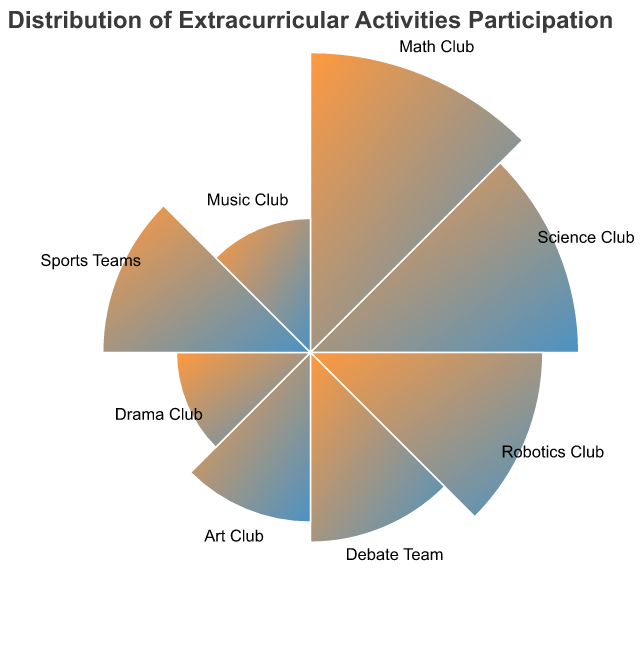What is the highest participation percentage? By examining the lengths of the radial sections, the Math Club has the highest participation rate of 25%.
Answer: 25% Which club has the next highest participation after the Math Club? By comparing the radial lengths, the Science Club has the next highest participation rate of 20% after the Math Club.
Answer: Science Club What is the combined participation percentage of all STEM-related clubs? The STEM-related clubs are Math, Science, and Robotics. Adding their percentages: 25% (Math) + 20% (Science) + 15% (Robotics) = 60%.
Answer: 60% Which non-STEM club has the highest participation? By comparing the non-STEM clubs on the chart, the Debate Team has the highest participation at 10%.
Answer: Debate Team How much more participation does the Math Club have compared to the Robotics Club? The Math Club’s participation is 25%, while the Robotics Club’s is 15%. The difference is 25% - 15% = 10%.
Answer: 10% What is the average participation percentage across all clubs? Sum the participation percentages: 25 + 20 + 15 + 10 + 8 + 5 + 12 + 5 = 100. There are 8 categories, so the average is 100/8 = 12.5%.
Answer: 12.5% Which club has the lowest participation percentage? The shortest radial sections will indicate the lowest participation, which are Drama Club and Music Club, both with 5%.
Answer: Drama Club, Music Club By how many percentage points does the participation in the Sports Teams exceed that of the Art Club? Sports Teams have 12%, and the Art Club has 8%. The difference is 12% - 8% = 4%.
Answer: 4% List the clubs with participation greater than 10%. Identify the radial sections greater than 10%: Math Club (25%), Science Club (20%), Robotics Club (15%), and Sports Teams (12%).
Answer: Math Club, Science Club, Robotics Club, Sports Teams 